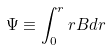Convert formula to latex. <formula><loc_0><loc_0><loc_500><loc_500>\Psi \equiv \int _ { 0 } ^ { r } r B d r</formula> 